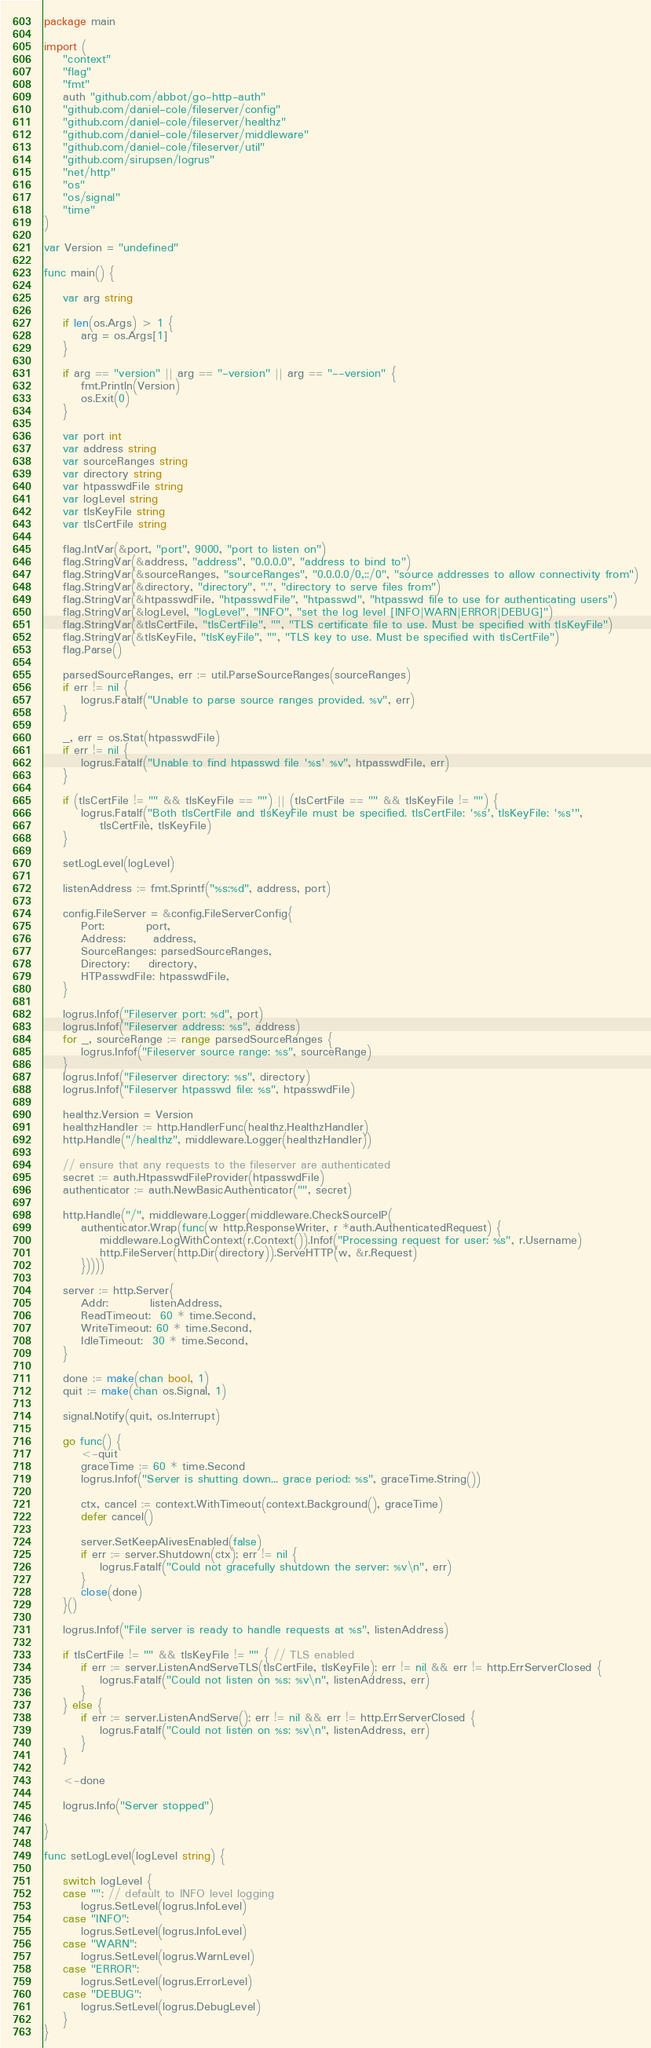<code> <loc_0><loc_0><loc_500><loc_500><_Go_>package main

import (
	"context"
	"flag"
	"fmt"
	auth "github.com/abbot/go-http-auth"
	"github.com/daniel-cole/fileserver/config"
	"github.com/daniel-cole/fileserver/healthz"
	"github.com/daniel-cole/fileserver/middleware"
	"github.com/daniel-cole/fileserver/util"
	"github.com/sirupsen/logrus"
	"net/http"
	"os"
	"os/signal"
	"time"
)

var Version = "undefined"

func main() {

	var arg string

	if len(os.Args) > 1 {
		arg = os.Args[1]
	}

	if arg == "version" || arg == "-version" || arg == "--version" {
		fmt.Println(Version)
		os.Exit(0)
	}

	var port int
	var address string
	var sourceRanges string
	var directory string
	var htpasswdFile string
	var logLevel string
	var tlsKeyFile string
	var tlsCertFile string

	flag.IntVar(&port, "port", 9000, "port to listen on")
	flag.StringVar(&address, "address", "0.0.0.0", "address to bind to")
	flag.StringVar(&sourceRanges, "sourceRanges", "0.0.0.0/0,::/0", "source addresses to allow connectivity from")
	flag.StringVar(&directory, "directory", ".", "directory to serve files from")
	flag.StringVar(&htpasswdFile, "htpasswdFile", "htpasswd", "htpasswd file to use for authenticating users")
	flag.StringVar(&logLevel, "logLevel", "INFO", "set the log level [INFO|WARN|ERROR|DEBUG]")
	flag.StringVar(&tlsCertFile, "tlsCertFile", "", "TLS certificate file to use. Must be specified with tlsKeyFile")
	flag.StringVar(&tlsKeyFile, "tlsKeyFile", "", "TLS key to use. Must be specified with tlsCertFile")
	flag.Parse()

	parsedSourceRanges, err := util.ParseSourceRanges(sourceRanges)
	if err != nil {
		logrus.Fatalf("Unable to parse source ranges provided. %v", err)
	}

	_, err = os.Stat(htpasswdFile)
	if err != nil {
		logrus.Fatalf("Unable to find htpasswd file '%s' %v", htpasswdFile, err)
	}

	if (tlsCertFile != "" && tlsKeyFile == "") || (tlsCertFile == "" && tlsKeyFile != "") {
		logrus.Fatalf("Both tlsCertFile and tlsKeyFile must be specified. tlsCertFile: '%s', tlsKeyFile: '%s'",
			tlsCertFile, tlsKeyFile)
	}

	setLogLevel(logLevel)

	listenAddress := fmt.Sprintf("%s:%d", address, port)

	config.FileServer = &config.FileServerConfig{
		Port:         port,
		Address:      address,
		SourceRanges: parsedSourceRanges,
		Directory:    directory,
		HTPasswdFile: htpasswdFile,
	}

	logrus.Infof("Fileserver port: %d", port)
	logrus.Infof("Fileserver address: %s", address)
	for _, sourceRange := range parsedSourceRanges {
		logrus.Infof("Fileserver source range: %s", sourceRange)
	}
	logrus.Infof("Fileserver directory: %s", directory)
	logrus.Infof("Fileserver htpasswd file: %s", htpasswdFile)

	healthz.Version = Version
	healthzHandler := http.HandlerFunc(healthz.HealthzHandler)
	http.Handle("/healthz", middleware.Logger(healthzHandler))

	// ensure that any requests to the fileserver are authenticated
	secret := auth.HtpasswdFileProvider(htpasswdFile)
	authenticator := auth.NewBasicAuthenticator("", secret)

	http.Handle("/", middleware.Logger(middleware.CheckSourceIP(
		authenticator.Wrap(func(w http.ResponseWriter, r *auth.AuthenticatedRequest) {
			middleware.LogWithContext(r.Context()).Infof("Processing request for user: %s", r.Username)
			http.FileServer(http.Dir(directory)).ServeHTTP(w, &r.Request)
		}))))

	server := http.Server{
		Addr:         listenAddress,
		ReadTimeout:  60 * time.Second,
		WriteTimeout: 60 * time.Second,
		IdleTimeout:  30 * time.Second,
	}

	done := make(chan bool, 1)
	quit := make(chan os.Signal, 1)

	signal.Notify(quit, os.Interrupt)

	go func() {
		<-quit
		graceTime := 60 * time.Second
		logrus.Infof("Server is shutting down... grace period: %s", graceTime.String())

		ctx, cancel := context.WithTimeout(context.Background(), graceTime)
		defer cancel()

		server.SetKeepAlivesEnabled(false)
		if err := server.Shutdown(ctx); err != nil {
			logrus.Fatalf("Could not gracefully shutdown the server: %v\n", err)
		}
		close(done)
	}()

	logrus.Infof("File server is ready to handle requests at %s", listenAddress)

	if tlsCertFile != "" && tlsKeyFile != "" { // TLS enabled
		if err := server.ListenAndServeTLS(tlsCertFile, tlsKeyFile); err != nil && err != http.ErrServerClosed {
			logrus.Fatalf("Could not listen on %s: %v\n", listenAddress, err)
		}
	} else {
		if err := server.ListenAndServe(); err != nil && err != http.ErrServerClosed {
			logrus.Fatalf("Could not listen on %s: %v\n", listenAddress, err)
		}
	}

	<-done

	logrus.Info("Server stopped")

}

func setLogLevel(logLevel string) {

	switch logLevel {
	case "": // default to INFO level logging
		logrus.SetLevel(logrus.InfoLevel)
	case "INFO":
		logrus.SetLevel(logrus.InfoLevel)
	case "WARN":
		logrus.SetLevel(logrus.WarnLevel)
	case "ERROR":
		logrus.SetLevel(logrus.ErrorLevel)
	case "DEBUG":
		logrus.SetLevel(logrus.DebugLevel)
	}
}
</code> 